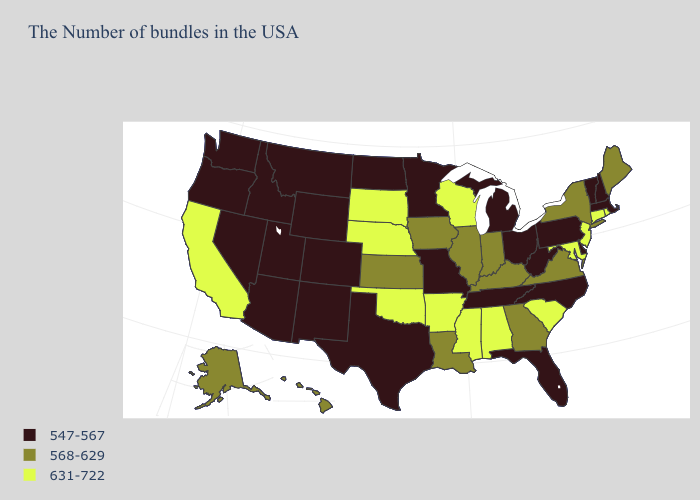Among the states that border Virginia , which have the highest value?
Quick response, please. Maryland. Name the states that have a value in the range 547-567?
Answer briefly. Massachusetts, New Hampshire, Vermont, Delaware, Pennsylvania, North Carolina, West Virginia, Ohio, Florida, Michigan, Tennessee, Missouri, Minnesota, Texas, North Dakota, Wyoming, Colorado, New Mexico, Utah, Montana, Arizona, Idaho, Nevada, Washington, Oregon. Which states hav the highest value in the South?
Be succinct. Maryland, South Carolina, Alabama, Mississippi, Arkansas, Oklahoma. Which states have the highest value in the USA?
Quick response, please. Rhode Island, Connecticut, New Jersey, Maryland, South Carolina, Alabama, Wisconsin, Mississippi, Arkansas, Nebraska, Oklahoma, South Dakota, California. Which states have the highest value in the USA?
Give a very brief answer. Rhode Island, Connecticut, New Jersey, Maryland, South Carolina, Alabama, Wisconsin, Mississippi, Arkansas, Nebraska, Oklahoma, South Dakota, California. Name the states that have a value in the range 631-722?
Give a very brief answer. Rhode Island, Connecticut, New Jersey, Maryland, South Carolina, Alabama, Wisconsin, Mississippi, Arkansas, Nebraska, Oklahoma, South Dakota, California. Name the states that have a value in the range 631-722?
Answer briefly. Rhode Island, Connecticut, New Jersey, Maryland, South Carolina, Alabama, Wisconsin, Mississippi, Arkansas, Nebraska, Oklahoma, South Dakota, California. Name the states that have a value in the range 568-629?
Keep it brief. Maine, New York, Virginia, Georgia, Kentucky, Indiana, Illinois, Louisiana, Iowa, Kansas, Alaska, Hawaii. Name the states that have a value in the range 568-629?
Keep it brief. Maine, New York, Virginia, Georgia, Kentucky, Indiana, Illinois, Louisiana, Iowa, Kansas, Alaska, Hawaii. Among the states that border Michigan , does Indiana have the lowest value?
Answer briefly. No. What is the value of New Jersey?
Short answer required. 631-722. What is the value of Oklahoma?
Answer briefly. 631-722. Is the legend a continuous bar?
Give a very brief answer. No. What is the lowest value in the USA?
Short answer required. 547-567. 